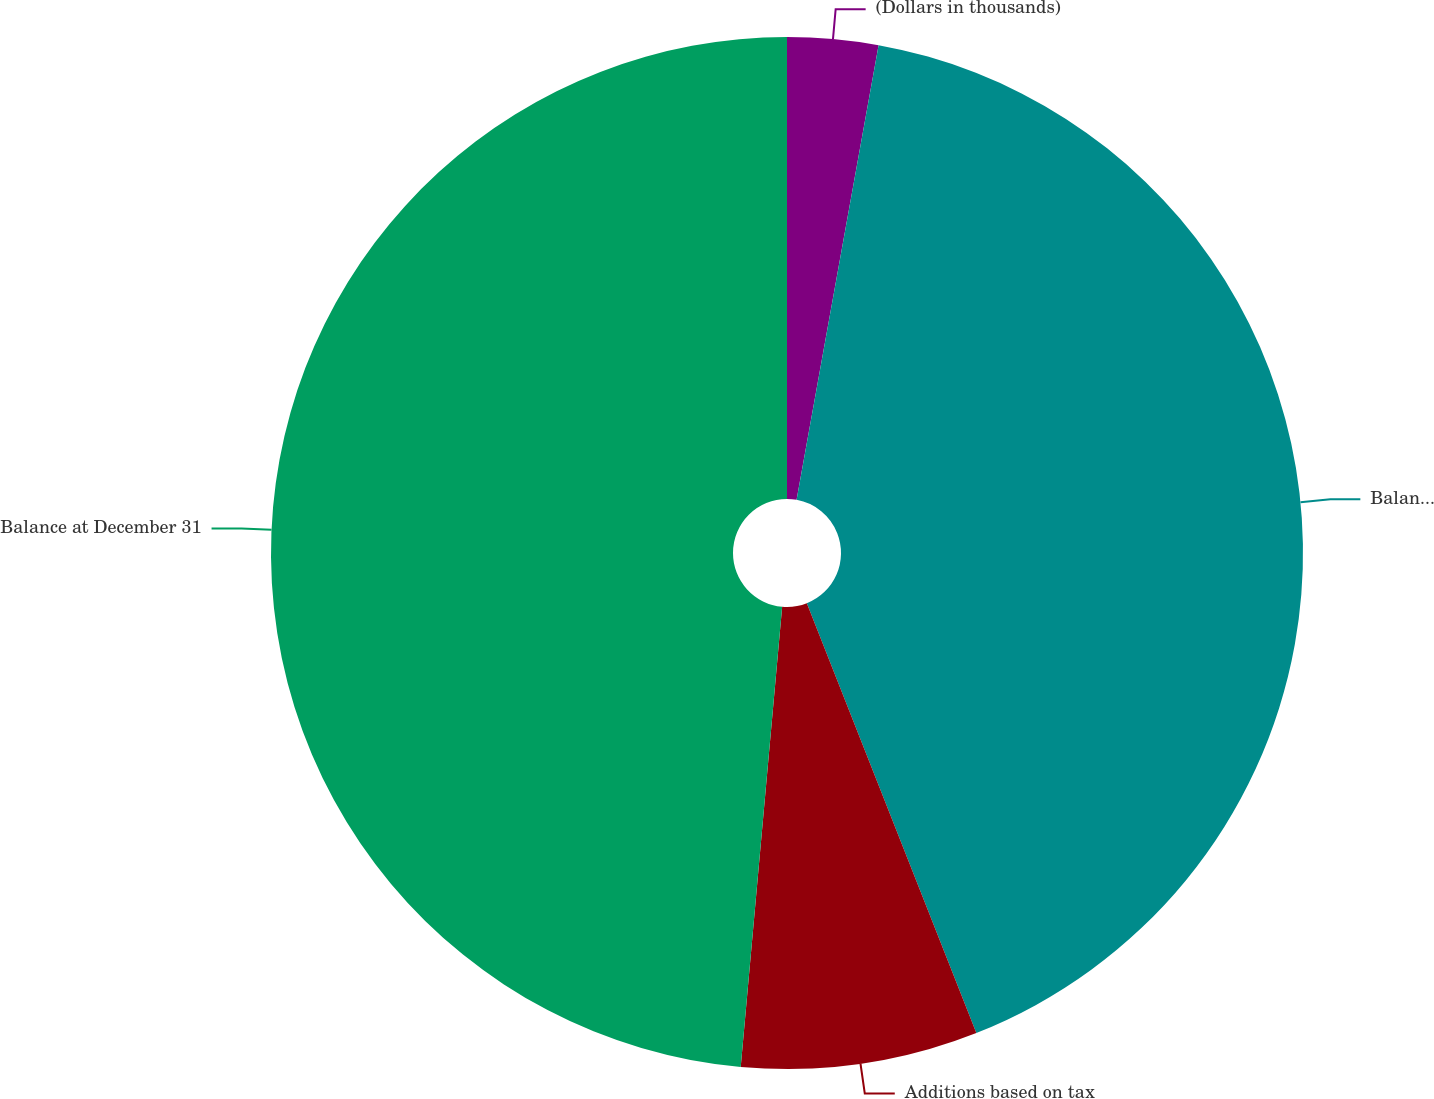<chart> <loc_0><loc_0><loc_500><loc_500><pie_chart><fcel>(Dollars in thousands)<fcel>Balance at January 1<fcel>Additions based on tax<fcel>Balance at December 31<nl><fcel>2.84%<fcel>41.18%<fcel>7.41%<fcel>48.57%<nl></chart> 